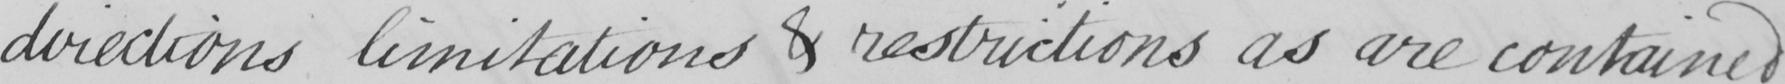Can you read and transcribe this handwriting? directions limitations & restrictions as are contained 